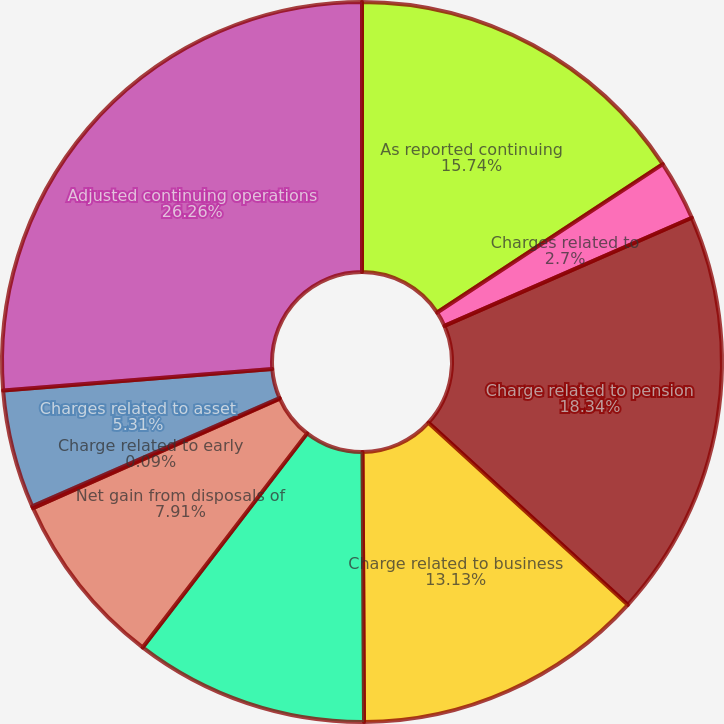Convert chart to OTSL. <chart><loc_0><loc_0><loc_500><loc_500><pie_chart><fcel>As reported continuing<fcel>Charges related to<fcel>Charge related to pension<fcel>Charge related to business<fcel>Charge related to<fcel>Net gain from disposals of<fcel>Charge related to early<fcel>Charges related to asset<fcel>Adjusted continuing operations<nl><fcel>15.74%<fcel>2.7%<fcel>18.34%<fcel>13.13%<fcel>10.52%<fcel>7.91%<fcel>0.09%<fcel>5.31%<fcel>26.26%<nl></chart> 